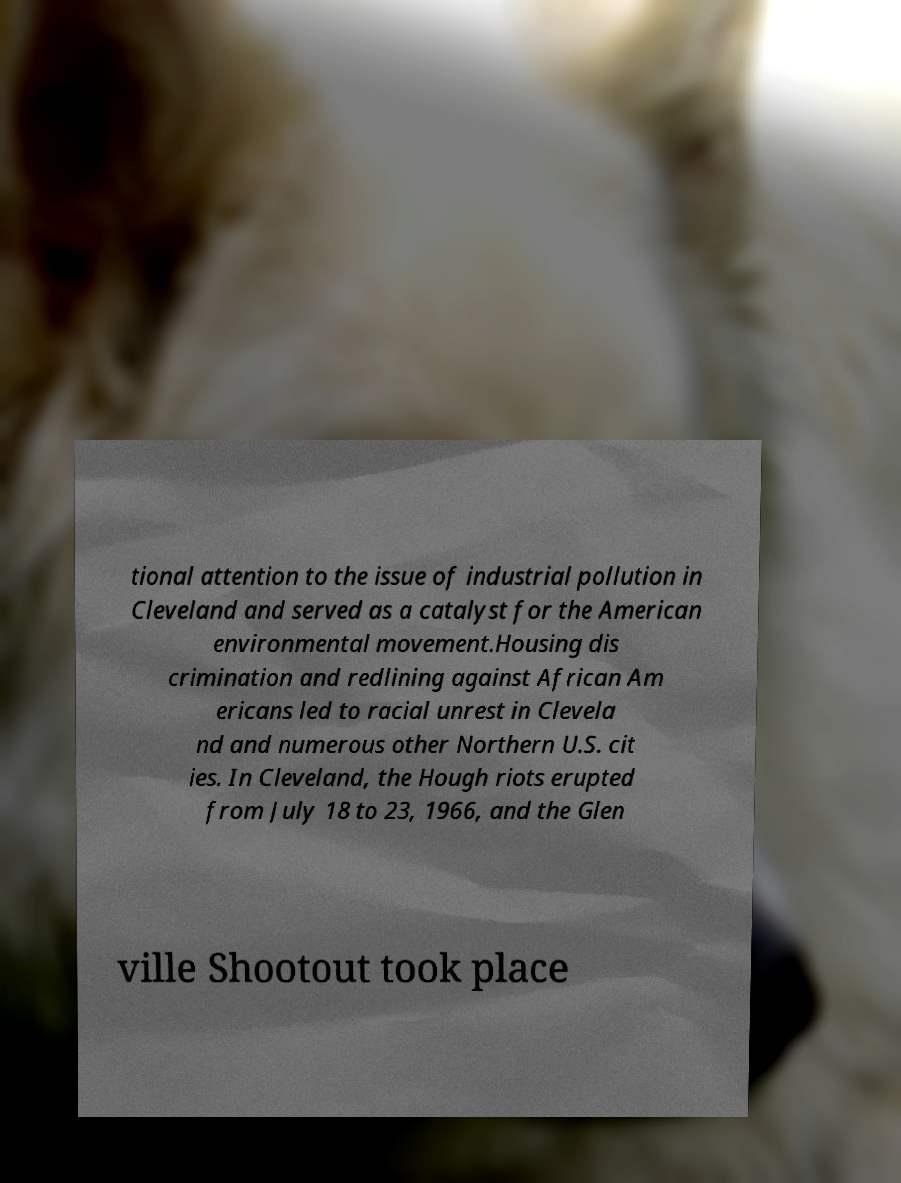Could you assist in decoding the text presented in this image and type it out clearly? tional attention to the issue of industrial pollution in Cleveland and served as a catalyst for the American environmental movement.Housing dis crimination and redlining against African Am ericans led to racial unrest in Clevela nd and numerous other Northern U.S. cit ies. In Cleveland, the Hough riots erupted from July 18 to 23, 1966, and the Glen ville Shootout took place 